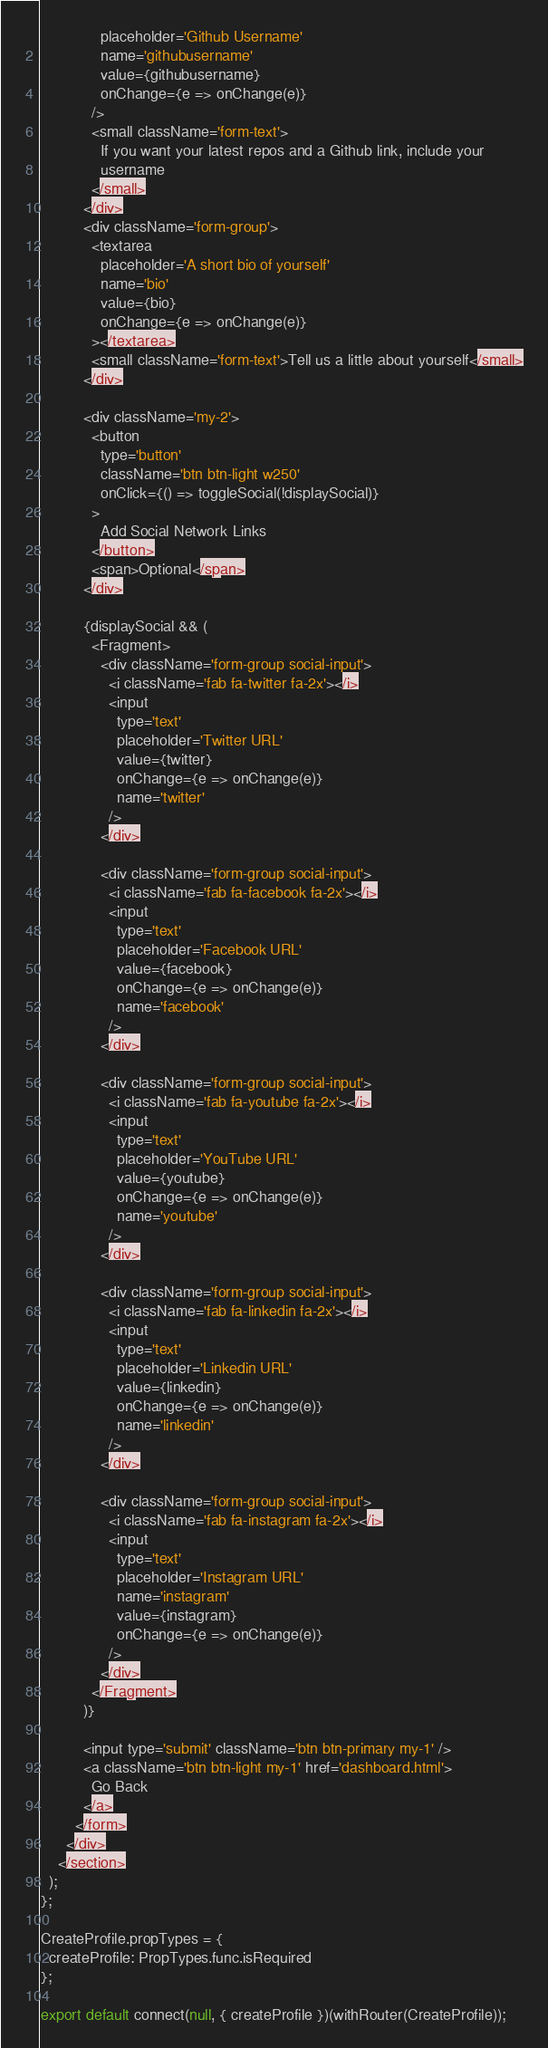<code> <loc_0><loc_0><loc_500><loc_500><_JavaScript_>              placeholder='Github Username'
              name='githubusername'
              value={githubusername}
              onChange={e => onChange(e)}
            />
            <small className='form-text'>
              If you want your latest repos and a Github link, include your
              username
            </small>
          </div>
          <div className='form-group'>
            <textarea
              placeholder='A short bio of yourself'
              name='bio'
              value={bio}
              onChange={e => onChange(e)}
            ></textarea>
            <small className='form-text'>Tell us a little about yourself</small>
          </div>

          <div className='my-2'>
            <button
              type='button'
              className='btn btn-light w250'
              onClick={() => toggleSocial(!displaySocial)}
            >
              Add Social Network Links
            </button>
            <span>Optional</span>
          </div>

          {displaySocial && (
            <Fragment>
              <div className='form-group social-input'>
                <i className='fab fa-twitter fa-2x'></i>
                <input
                  type='text'
                  placeholder='Twitter URL'
                  value={twitter}
                  onChange={e => onChange(e)}
                  name='twitter'
                />
              </div>

              <div className='form-group social-input'>
                <i className='fab fa-facebook fa-2x'></i>
                <input
                  type='text'
                  placeholder='Facebook URL'
                  value={facebook}
                  onChange={e => onChange(e)}
                  name='facebook'
                />
              </div>

              <div className='form-group social-input'>
                <i className='fab fa-youtube fa-2x'></i>
                <input
                  type='text'
                  placeholder='YouTube URL'
                  value={youtube}
                  onChange={e => onChange(e)}
                  name='youtube'
                />
              </div>

              <div className='form-group social-input'>
                <i className='fab fa-linkedin fa-2x'></i>
                <input
                  type='text'
                  placeholder='Linkedin URL'
                  value={linkedin}
                  onChange={e => onChange(e)}
                  name='linkedin'
                />
              </div>

              <div className='form-group social-input'>
                <i className='fab fa-instagram fa-2x'></i>
                <input
                  type='text'
                  placeholder='Instagram URL'
                  name='instagram'
                  value={instagram}
                  onChange={e => onChange(e)}
                />
              </div>
            </Fragment>
          )}

          <input type='submit' className='btn btn-primary my-1' />
          <a className='btn btn-light my-1' href='dashboard.html'>
            Go Back
          </a>
        </form>
      </div>
    </section>
  );
};

CreateProfile.propTypes = {
  createProfile: PropTypes.func.isRequired
};

export default connect(null, { createProfile })(withRouter(CreateProfile));
</code> 